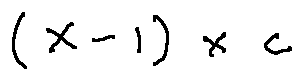<formula> <loc_0><loc_0><loc_500><loc_500>( X - 1 ) \times c</formula> 